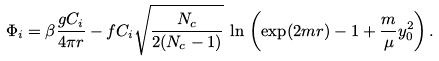<formula> <loc_0><loc_0><loc_500><loc_500>\Phi _ { i } = \beta \frac { g C _ { i } } { 4 \pi r } - f C _ { i } \sqrt { \frac { N _ { c } } { 2 ( N _ { c } - 1 ) } } \, \ln \, \left ( \exp ( 2 m r ) - 1 + \frac { m } { \mu } y _ { 0 } ^ { 2 } \right ) .</formula> 